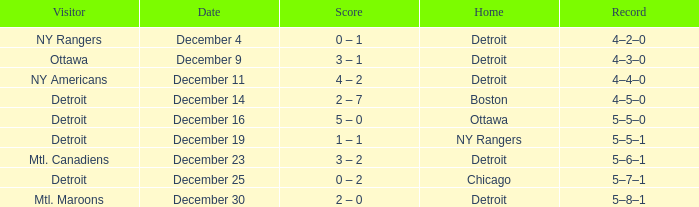What score has mtl. maroons as the visitor? 2 – 0. 